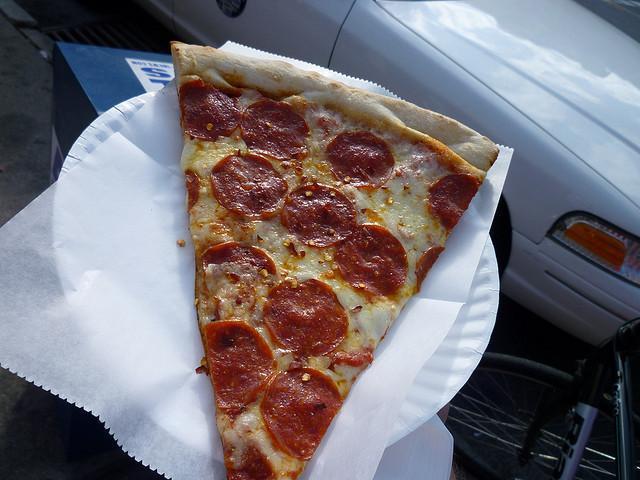How many people are wearing a hat?
Give a very brief answer. 0. 